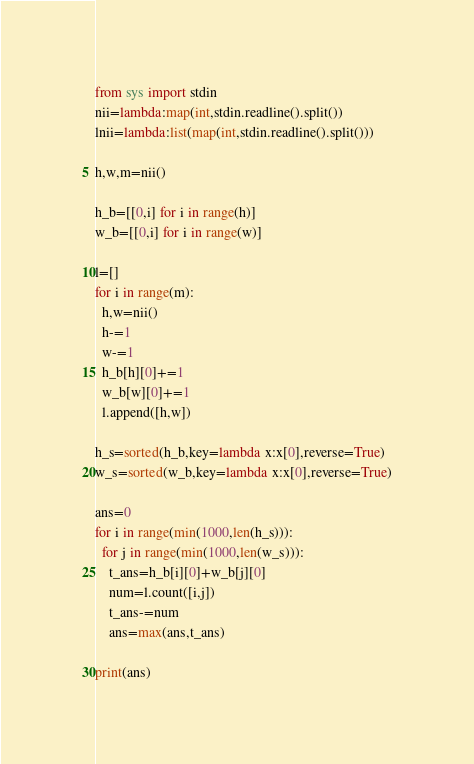<code> <loc_0><loc_0><loc_500><loc_500><_Python_>from sys import stdin
nii=lambda:map(int,stdin.readline().split())
lnii=lambda:list(map(int,stdin.readline().split()))

h,w,m=nii()

h_b=[[0,i] for i in range(h)]
w_b=[[0,i] for i in range(w)]

l=[]
for i in range(m):
  h,w=nii()
  h-=1
  w-=1
  h_b[h][0]+=1
  w_b[w][0]+=1
  l.append([h,w])

h_s=sorted(h_b,key=lambda x:x[0],reverse=True)
w_s=sorted(w_b,key=lambda x:x[0],reverse=True)

ans=0
for i in range(min(1000,len(h_s))):
  for j in range(min(1000,len(w_s))):
    t_ans=h_b[i][0]+w_b[j][0]
    num=l.count([i,j])
    t_ans-=num
    ans=max(ans,t_ans)

print(ans)</code> 